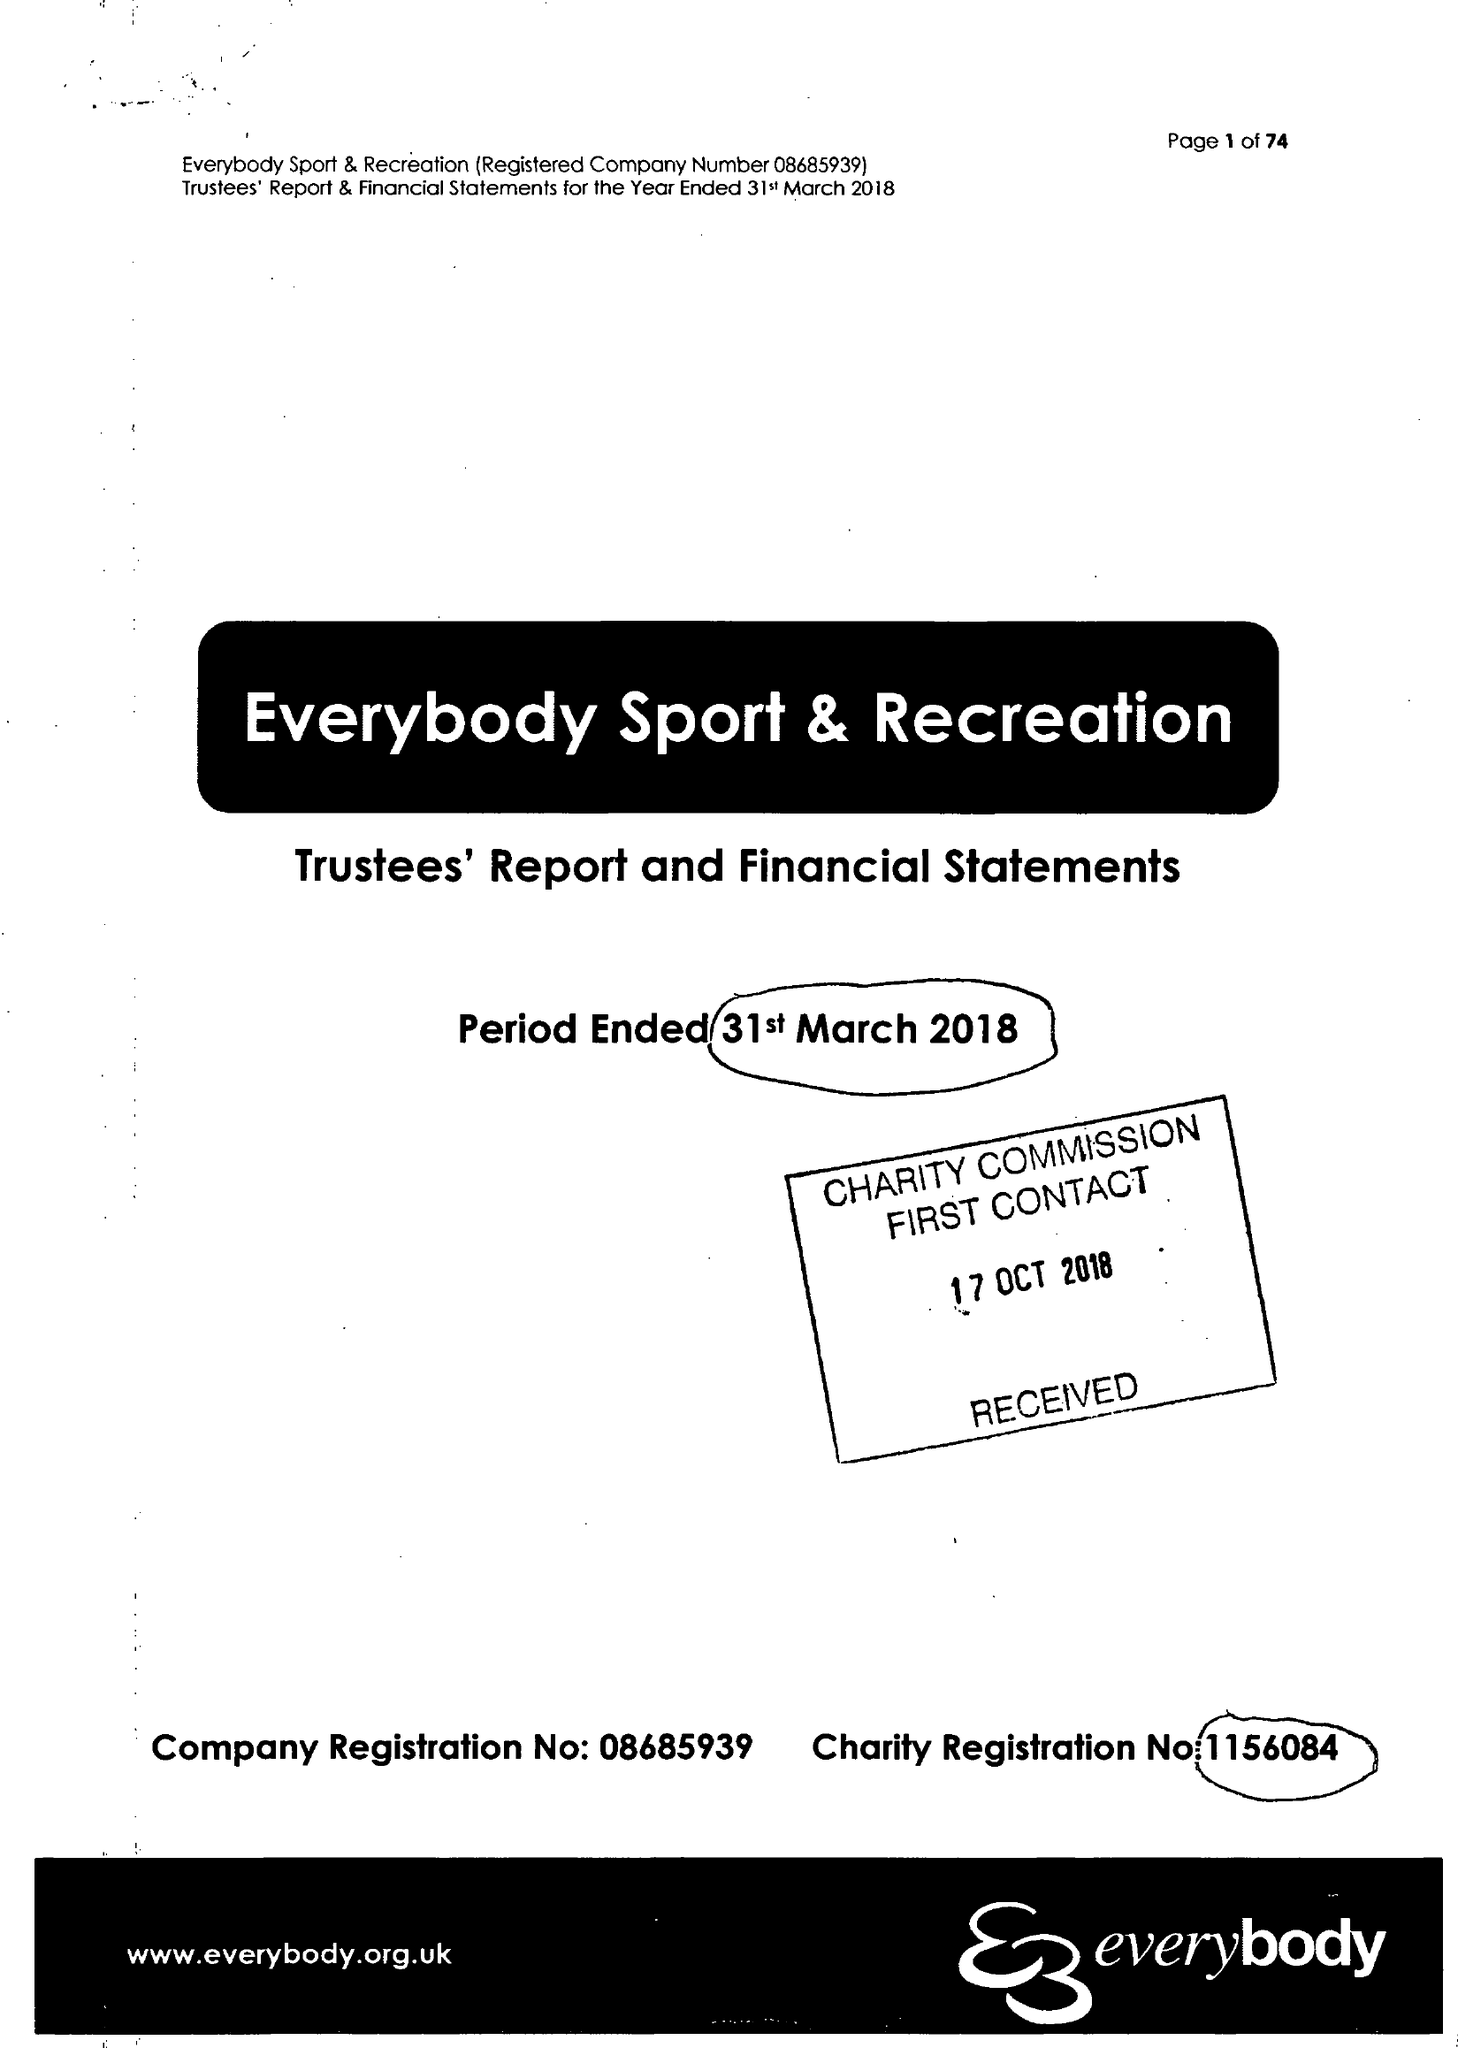What is the value for the spending_annually_in_british_pounds?
Answer the question using a single word or phrase. 16245061.00 